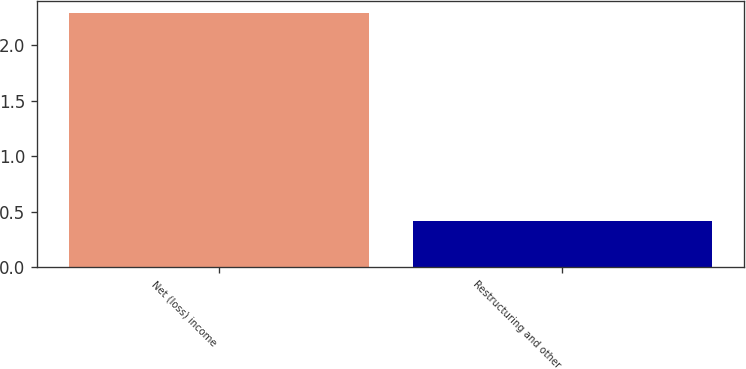Convert chart. <chart><loc_0><loc_0><loc_500><loc_500><bar_chart><fcel>Net (loss) income<fcel>Restructuring and other<nl><fcel>2.29<fcel>0.42<nl></chart> 